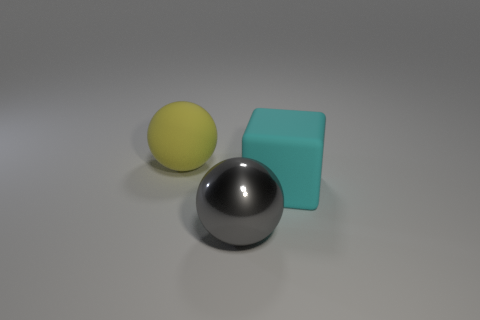Add 3 large cyan rubber blocks. How many objects exist? 6 Subtract all spheres. How many objects are left? 1 Subtract 0 brown balls. How many objects are left? 3 Subtract all yellow rubber blocks. Subtract all big gray things. How many objects are left? 2 Add 1 yellow rubber balls. How many yellow rubber balls are left? 2 Add 3 large yellow rubber balls. How many large yellow rubber balls exist? 4 